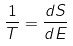<formula> <loc_0><loc_0><loc_500><loc_500>\frac { 1 } { T } = \frac { d S } { d E }</formula> 